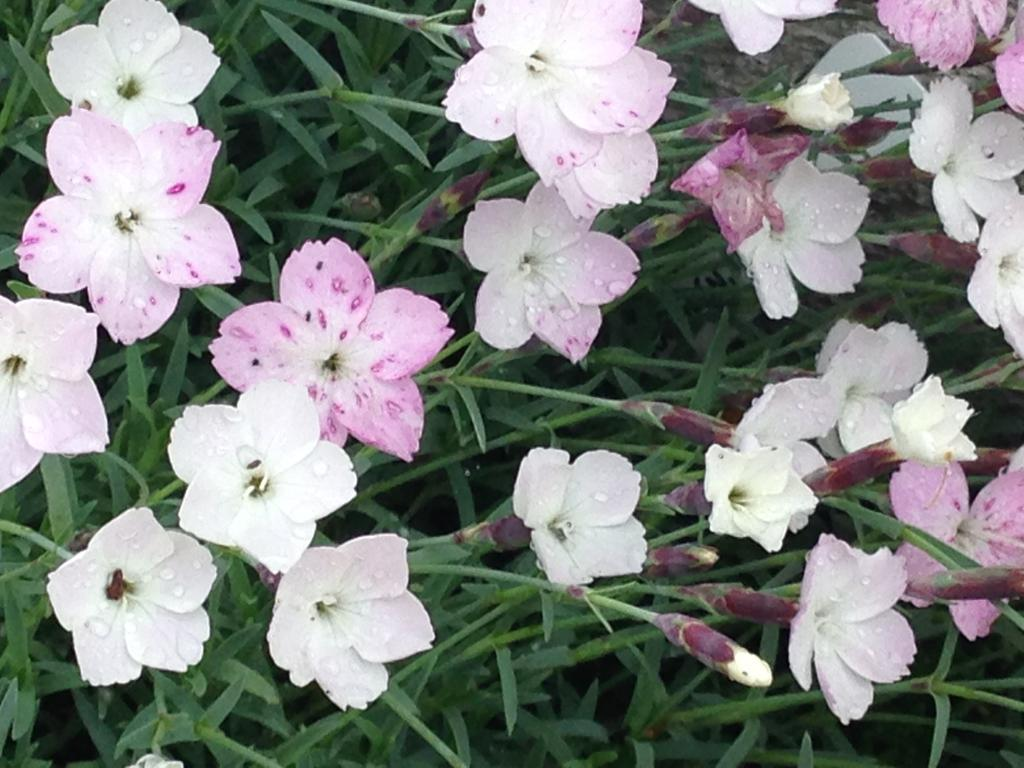Where was the image taken? The image was taken outdoors. What type of vegetation can be seen at the bottom of the image? There is grass with flowers at the bottom of the image. What color are the flowers in the image? The flowers are pink in color. How many chickens are present in the image? There are no chickens present in the image. What is the purpose of the flowers in the image? The image does not provide information about the purpose of the flowers. 